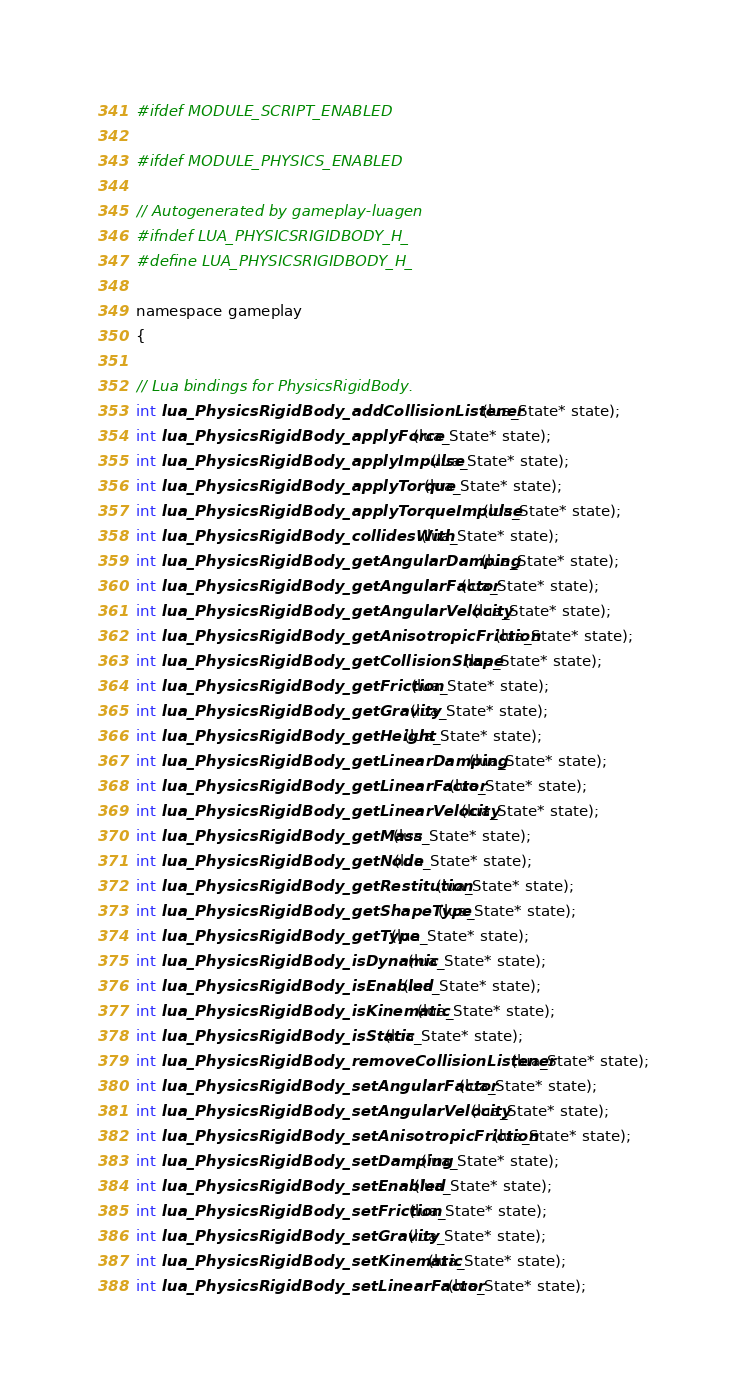Convert code to text. <code><loc_0><loc_0><loc_500><loc_500><_C_>#ifdef MODULE_SCRIPT_ENABLED

#ifdef MODULE_PHYSICS_ENABLED

// Autogenerated by gameplay-luagen
#ifndef LUA_PHYSICSRIGIDBODY_H_
#define LUA_PHYSICSRIGIDBODY_H_

namespace gameplay
{

// Lua bindings for PhysicsRigidBody.
int lua_PhysicsRigidBody_addCollisionListener(lua_State* state);
int lua_PhysicsRigidBody_applyForce(lua_State* state);
int lua_PhysicsRigidBody_applyImpulse(lua_State* state);
int lua_PhysicsRigidBody_applyTorque(lua_State* state);
int lua_PhysicsRigidBody_applyTorqueImpulse(lua_State* state);
int lua_PhysicsRigidBody_collidesWith(lua_State* state);
int lua_PhysicsRigidBody_getAngularDamping(lua_State* state);
int lua_PhysicsRigidBody_getAngularFactor(lua_State* state);
int lua_PhysicsRigidBody_getAngularVelocity(lua_State* state);
int lua_PhysicsRigidBody_getAnisotropicFriction(lua_State* state);
int lua_PhysicsRigidBody_getCollisionShape(lua_State* state);
int lua_PhysicsRigidBody_getFriction(lua_State* state);
int lua_PhysicsRigidBody_getGravity(lua_State* state);
int lua_PhysicsRigidBody_getHeight(lua_State* state);
int lua_PhysicsRigidBody_getLinearDamping(lua_State* state);
int lua_PhysicsRigidBody_getLinearFactor(lua_State* state);
int lua_PhysicsRigidBody_getLinearVelocity(lua_State* state);
int lua_PhysicsRigidBody_getMass(lua_State* state);
int lua_PhysicsRigidBody_getNode(lua_State* state);
int lua_PhysicsRigidBody_getRestitution(lua_State* state);
int lua_PhysicsRigidBody_getShapeType(lua_State* state);
int lua_PhysicsRigidBody_getType(lua_State* state);
int lua_PhysicsRigidBody_isDynamic(lua_State* state);
int lua_PhysicsRigidBody_isEnabled(lua_State* state);
int lua_PhysicsRigidBody_isKinematic(lua_State* state);
int lua_PhysicsRigidBody_isStatic(lua_State* state);
int lua_PhysicsRigidBody_removeCollisionListener(lua_State* state);
int lua_PhysicsRigidBody_setAngularFactor(lua_State* state);
int lua_PhysicsRigidBody_setAngularVelocity(lua_State* state);
int lua_PhysicsRigidBody_setAnisotropicFriction(lua_State* state);
int lua_PhysicsRigidBody_setDamping(lua_State* state);
int lua_PhysicsRigidBody_setEnabled(lua_State* state);
int lua_PhysicsRigidBody_setFriction(lua_State* state);
int lua_PhysicsRigidBody_setGravity(lua_State* state);
int lua_PhysicsRigidBody_setKinematic(lua_State* state);
int lua_PhysicsRigidBody_setLinearFactor(lua_State* state);</code> 